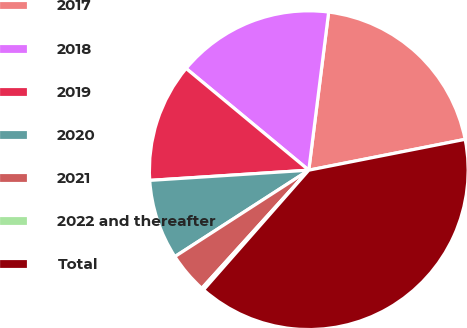Convert chart. <chart><loc_0><loc_0><loc_500><loc_500><pie_chart><fcel>2017<fcel>2018<fcel>2019<fcel>2020<fcel>2021<fcel>2022 and thereafter<fcel>Total<nl><fcel>19.91%<fcel>15.97%<fcel>12.04%<fcel>8.1%<fcel>4.17%<fcel>0.23%<fcel>39.58%<nl></chart> 